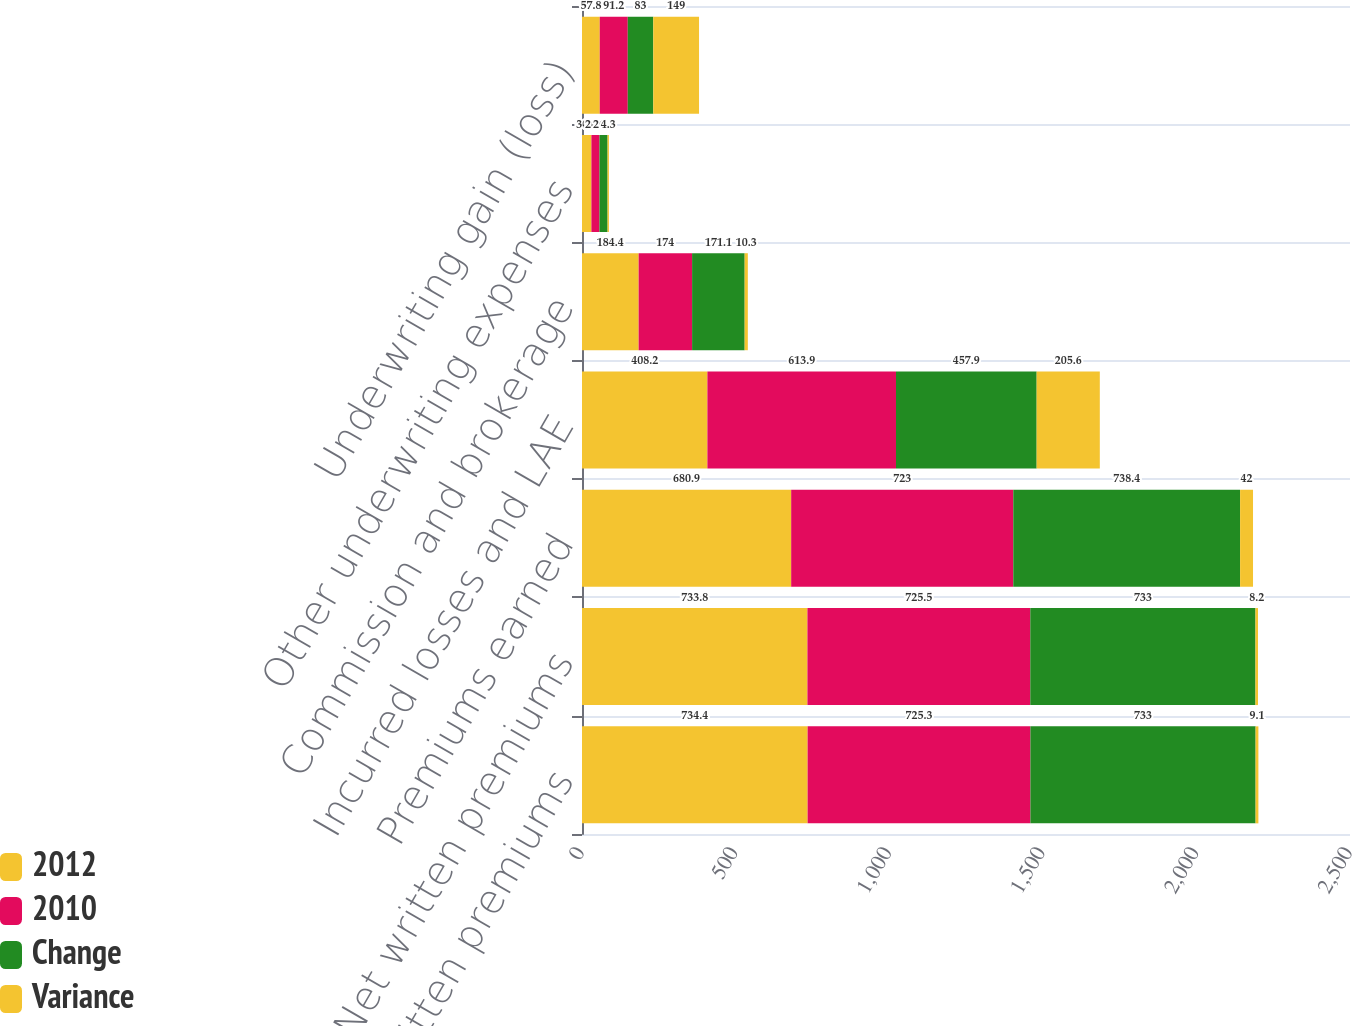<chart> <loc_0><loc_0><loc_500><loc_500><stacked_bar_chart><ecel><fcel>Gross written premiums<fcel>Net written premiums<fcel>Premiums earned<fcel>Incurred losses and LAE<fcel>Commission and brokerage<fcel>Other underwriting expenses<fcel>Underwriting gain (loss)<nl><fcel>2012<fcel>734.4<fcel>733.8<fcel>680.9<fcel>408.2<fcel>184.4<fcel>30.6<fcel>57.8<nl><fcel>2010<fcel>725.3<fcel>725.5<fcel>723<fcel>613.9<fcel>174<fcel>26.3<fcel>91.2<nl><fcel>Change<fcel>733<fcel>733<fcel>738.4<fcel>457.9<fcel>171.1<fcel>26.4<fcel>83<nl><fcel>Variance<fcel>9.1<fcel>8.2<fcel>42<fcel>205.6<fcel>10.3<fcel>4.3<fcel>149<nl></chart> 